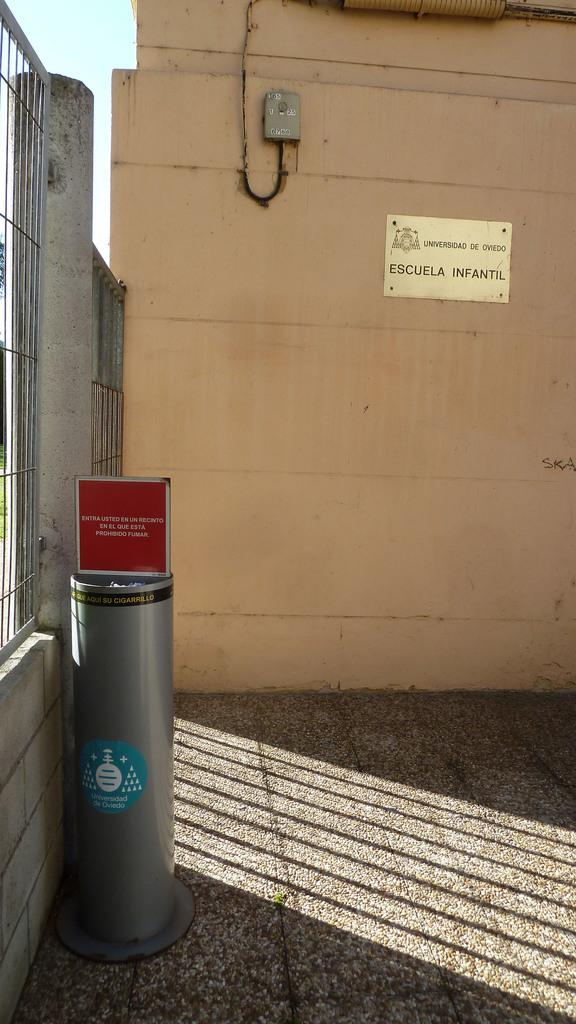<image>
Present a compact description of the photo's key features. A gold plaque that says Escuela Infantil is on a tan concrete wall. 